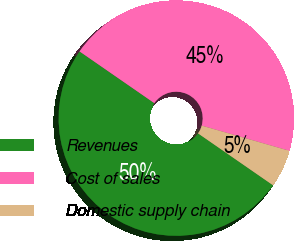Convert chart to OTSL. <chart><loc_0><loc_0><loc_500><loc_500><pie_chart><fcel>Revenues<fcel>Cost of sales<fcel>Domestic supply chain<nl><fcel>50.0%<fcel>44.82%<fcel>5.18%<nl></chart> 